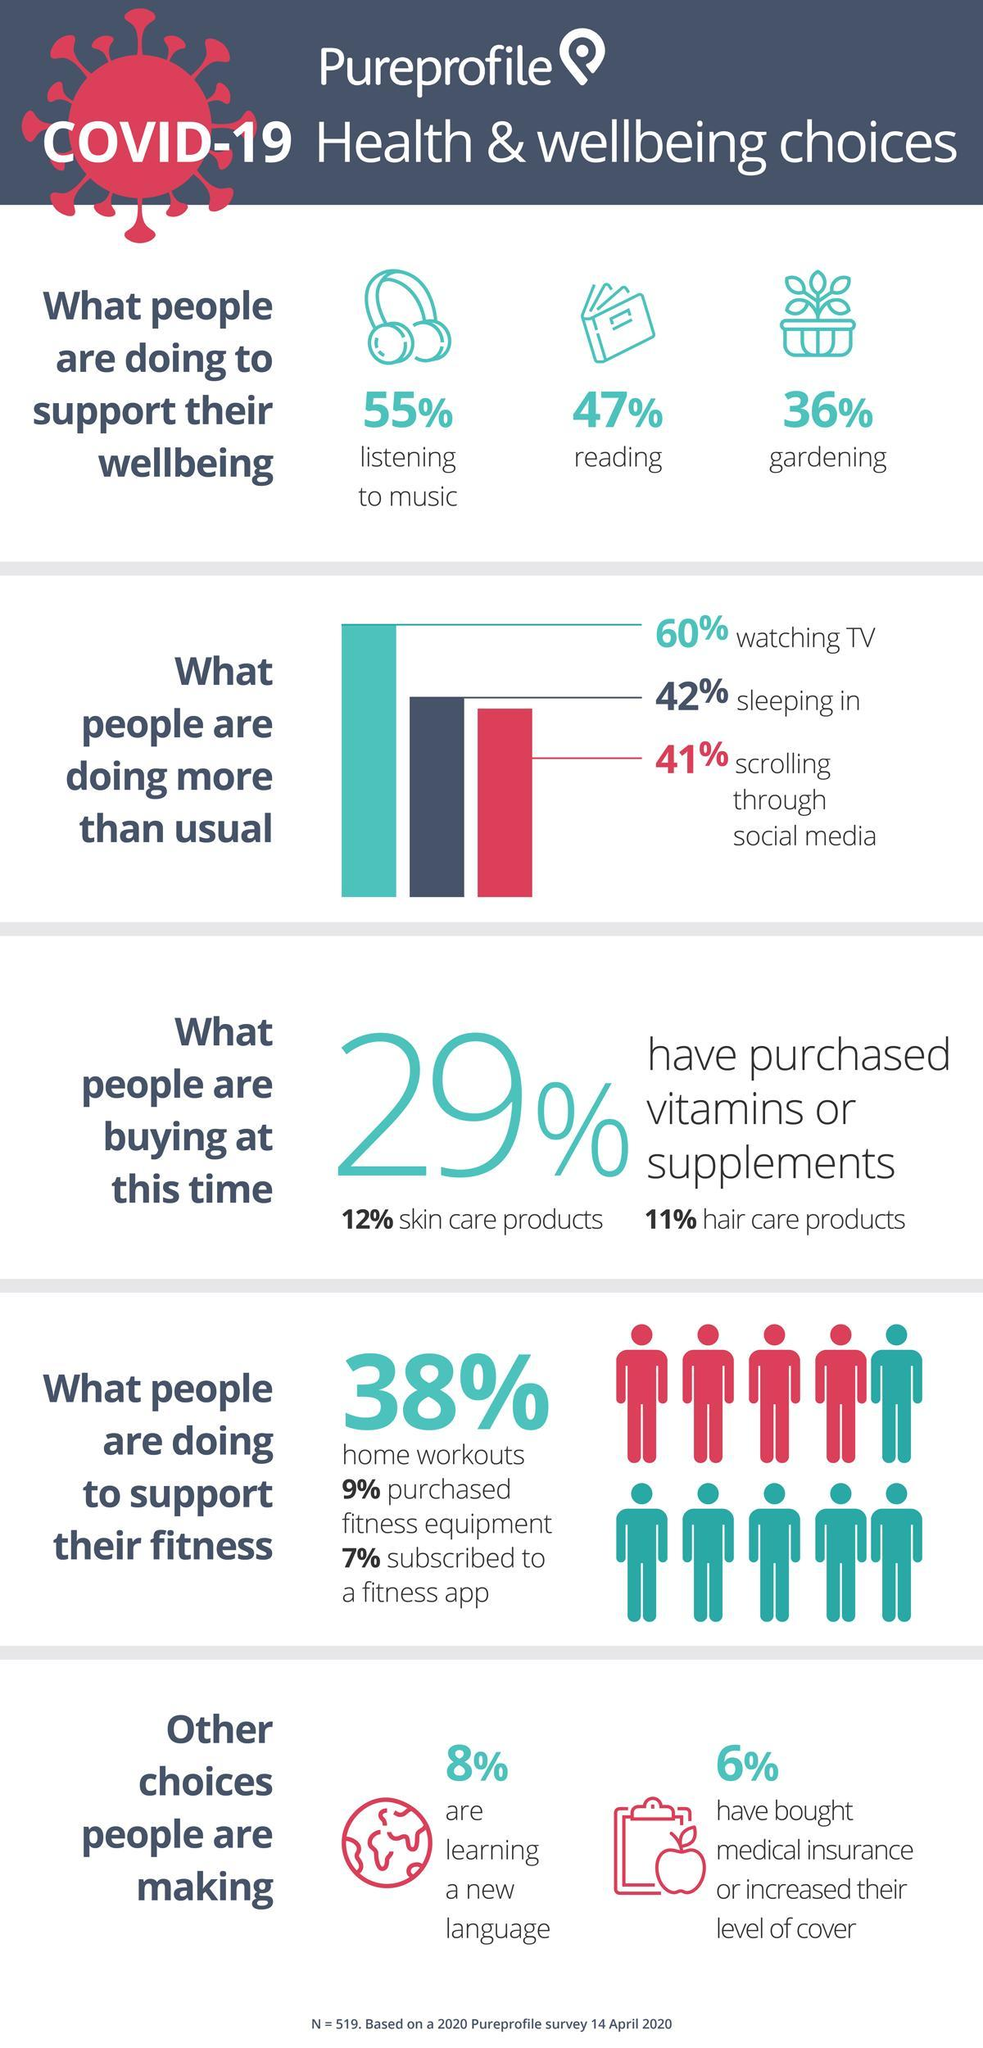What percentage work out at home?
Answer the question with a short phrase. 38% What percentage of people have turned to gardening to support their well being? 36% What percentage of people are reading to support their well being? 47% What are people buying mostly during these times? Vitamin or supplements, skin care products, hair care products What percentage of people are listening to music to support their wellbeing? 55% What percentage of people are learning a new language? 8% What 3 things are people doing more than usual? Watching TV, sleeping in, scrolling through social media By what percentage is watching TV more preferred than sleeping? 18% 